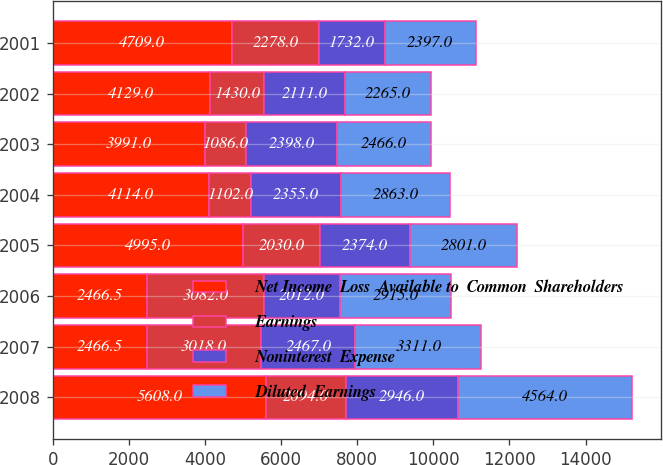<chart> <loc_0><loc_0><loc_500><loc_500><stacked_bar_chart><ecel><fcel>2008<fcel>2007<fcel>2006<fcel>2005<fcel>2004<fcel>2003<fcel>2002<fcel>2001<nl><fcel>Net Income  Loss  Available to  Common  Shareholders<fcel>5608<fcel>2466.5<fcel>2466.5<fcel>4995<fcel>4114<fcel>3991<fcel>4129<fcel>4709<nl><fcel>Earnings<fcel>2094<fcel>3018<fcel>3082<fcel>2030<fcel>1102<fcel>1086<fcel>1430<fcel>2278<nl><fcel>Noninterest  Expense<fcel>2946<fcel>2467<fcel>2012<fcel>2374<fcel>2355<fcel>2398<fcel>2111<fcel>1732<nl><fcel>Diluted  Earnings<fcel>4564<fcel>3311<fcel>2915<fcel>2801<fcel>2863<fcel>2466<fcel>2265<fcel>2397<nl></chart> 